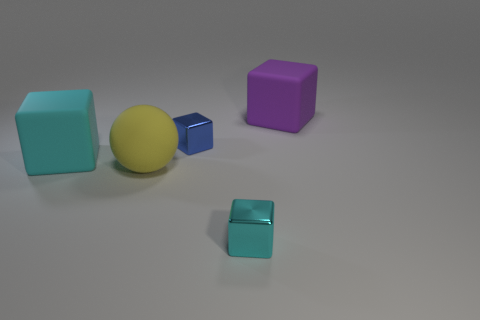There is a big cyan matte cube; are there any big yellow matte spheres left of it?
Make the answer very short. No. Is the large cube on the left side of the large purple thing made of the same material as the large purple cube?
Make the answer very short. Yes. Are there any other balls of the same color as the big rubber sphere?
Offer a terse response. No. What is the shape of the tiny blue metallic object?
Your response must be concise. Cube. The small cube behind the small thing that is to the right of the blue metallic object is what color?
Ensure brevity in your answer.  Blue. There is a matte thing that is behind the cyan matte cube; how big is it?
Make the answer very short. Large. Are there any yellow objects that have the same material as the large purple cube?
Your response must be concise. Yes. How many yellow rubber objects have the same shape as the tiny blue metallic object?
Your answer should be compact. 0. The cyan matte object behind the big object that is in front of the big matte block in front of the large purple rubber object is what shape?
Ensure brevity in your answer.  Cube. There is a object that is in front of the large cyan block and on the right side of the ball; what is its material?
Offer a very short reply. Metal. 